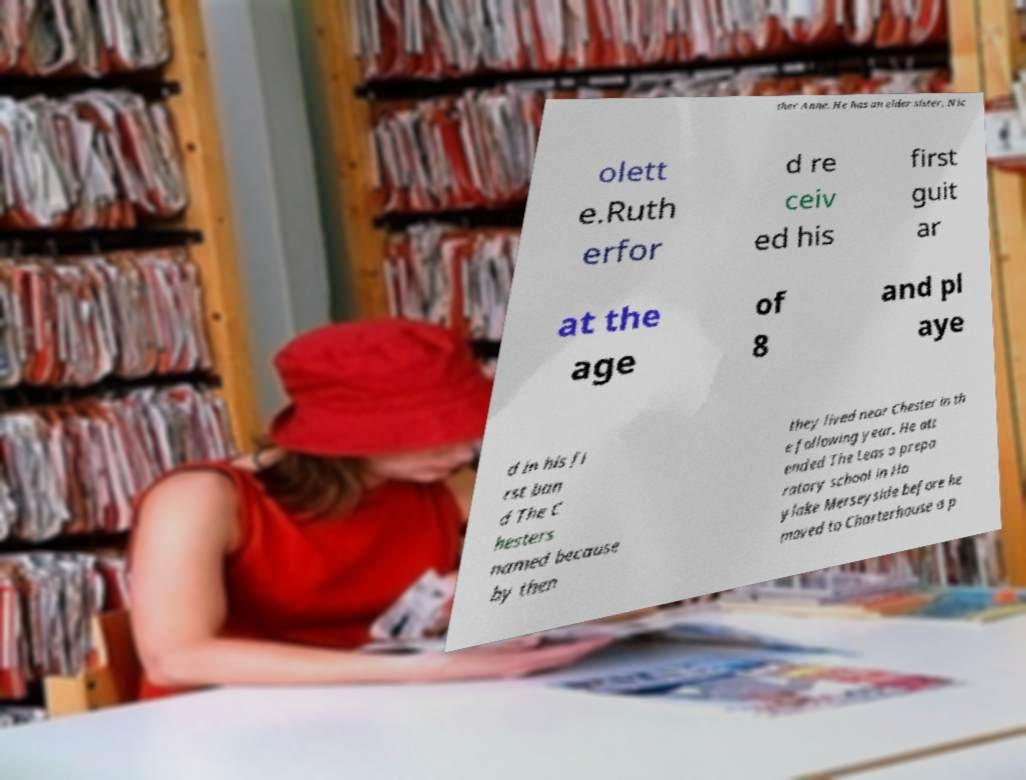Please identify and transcribe the text found in this image. ther Anne. He has an elder sister, Nic olett e.Ruth erfor d re ceiv ed his first guit ar at the age of 8 and pl aye d in his fi rst ban d The C hesters named because by then they lived near Chester in th e following year. He att ended The Leas a prepa ratory school in Ho ylake Merseyside before he moved to Charterhouse a p 